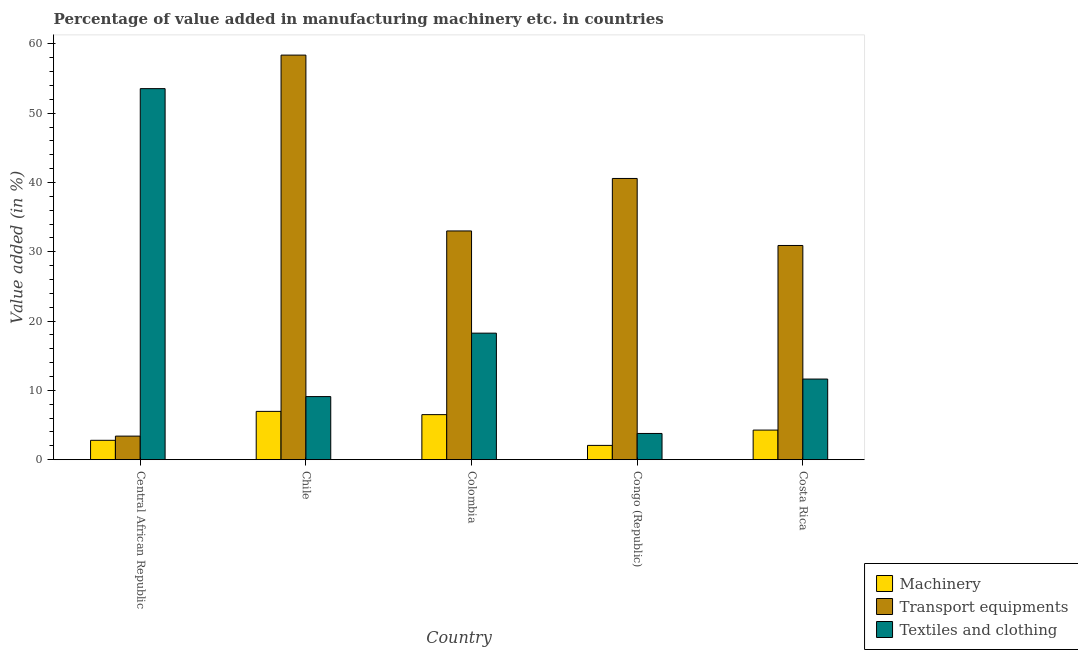How many groups of bars are there?
Keep it short and to the point. 5. Are the number of bars per tick equal to the number of legend labels?
Your answer should be compact. Yes. Are the number of bars on each tick of the X-axis equal?
Your answer should be compact. Yes. In how many cases, is the number of bars for a given country not equal to the number of legend labels?
Your response must be concise. 0. What is the value added in manufacturing machinery in Chile?
Ensure brevity in your answer.  6.97. Across all countries, what is the maximum value added in manufacturing transport equipments?
Your answer should be compact. 58.38. Across all countries, what is the minimum value added in manufacturing transport equipments?
Provide a succinct answer. 3.4. In which country was the value added in manufacturing textile and clothing minimum?
Provide a succinct answer. Congo (Republic). What is the total value added in manufacturing textile and clothing in the graph?
Make the answer very short. 96.33. What is the difference between the value added in manufacturing machinery in Congo (Republic) and that in Costa Rica?
Keep it short and to the point. -2.21. What is the difference between the value added in manufacturing textile and clothing in Central African Republic and the value added in manufacturing transport equipments in Costa Rica?
Your answer should be very brief. 22.63. What is the average value added in manufacturing machinery per country?
Provide a succinct answer. 4.52. What is the difference between the value added in manufacturing transport equipments and value added in manufacturing textile and clothing in Colombia?
Offer a very short reply. 14.75. In how many countries, is the value added in manufacturing transport equipments greater than 56 %?
Your answer should be compact. 1. What is the ratio of the value added in manufacturing textile and clothing in Congo (Republic) to that in Costa Rica?
Provide a succinct answer. 0.33. What is the difference between the highest and the second highest value added in manufacturing machinery?
Provide a short and direct response. 0.47. What is the difference between the highest and the lowest value added in manufacturing transport equipments?
Your answer should be very brief. 54.98. In how many countries, is the value added in manufacturing transport equipments greater than the average value added in manufacturing transport equipments taken over all countries?
Give a very brief answer. 2. What does the 3rd bar from the left in Congo (Republic) represents?
Offer a very short reply. Textiles and clothing. What does the 2nd bar from the right in Chile represents?
Make the answer very short. Transport equipments. Is it the case that in every country, the sum of the value added in manufacturing machinery and value added in manufacturing transport equipments is greater than the value added in manufacturing textile and clothing?
Give a very brief answer. No. How many bars are there?
Offer a very short reply. 15. How many countries are there in the graph?
Give a very brief answer. 5. Are the values on the major ticks of Y-axis written in scientific E-notation?
Keep it short and to the point. No. Does the graph contain any zero values?
Give a very brief answer. No. Does the graph contain grids?
Give a very brief answer. No. Where does the legend appear in the graph?
Offer a terse response. Bottom right. How many legend labels are there?
Your answer should be very brief. 3. What is the title of the graph?
Make the answer very short. Percentage of value added in manufacturing machinery etc. in countries. What is the label or title of the X-axis?
Offer a very short reply. Country. What is the label or title of the Y-axis?
Your answer should be very brief. Value added (in %). What is the Value added (in %) in Machinery in Central African Republic?
Your answer should be compact. 2.8. What is the Value added (in %) in Transport equipments in Central African Republic?
Provide a short and direct response. 3.4. What is the Value added (in %) of Textiles and clothing in Central African Republic?
Your answer should be compact. 53.54. What is the Value added (in %) in Machinery in Chile?
Give a very brief answer. 6.97. What is the Value added (in %) of Transport equipments in Chile?
Provide a succinct answer. 58.38. What is the Value added (in %) in Textiles and clothing in Chile?
Your response must be concise. 9.11. What is the Value added (in %) of Machinery in Colombia?
Your answer should be compact. 6.5. What is the Value added (in %) in Transport equipments in Colombia?
Ensure brevity in your answer.  33.01. What is the Value added (in %) of Textiles and clothing in Colombia?
Keep it short and to the point. 18.26. What is the Value added (in %) in Machinery in Congo (Republic)?
Keep it short and to the point. 2.06. What is the Value added (in %) in Transport equipments in Congo (Republic)?
Offer a terse response. 40.58. What is the Value added (in %) of Textiles and clothing in Congo (Republic)?
Provide a short and direct response. 3.79. What is the Value added (in %) of Machinery in Costa Rica?
Your response must be concise. 4.27. What is the Value added (in %) of Transport equipments in Costa Rica?
Your answer should be very brief. 30.91. What is the Value added (in %) of Textiles and clothing in Costa Rica?
Provide a short and direct response. 11.64. Across all countries, what is the maximum Value added (in %) of Machinery?
Provide a succinct answer. 6.97. Across all countries, what is the maximum Value added (in %) of Transport equipments?
Offer a terse response. 58.38. Across all countries, what is the maximum Value added (in %) of Textiles and clothing?
Your answer should be very brief. 53.54. Across all countries, what is the minimum Value added (in %) in Machinery?
Ensure brevity in your answer.  2.06. Across all countries, what is the minimum Value added (in %) of Transport equipments?
Keep it short and to the point. 3.4. Across all countries, what is the minimum Value added (in %) of Textiles and clothing?
Your response must be concise. 3.79. What is the total Value added (in %) in Machinery in the graph?
Provide a succinct answer. 22.61. What is the total Value added (in %) of Transport equipments in the graph?
Provide a short and direct response. 166.28. What is the total Value added (in %) of Textiles and clothing in the graph?
Give a very brief answer. 96.33. What is the difference between the Value added (in %) of Machinery in Central African Republic and that in Chile?
Provide a succinct answer. -4.17. What is the difference between the Value added (in %) in Transport equipments in Central African Republic and that in Chile?
Keep it short and to the point. -54.98. What is the difference between the Value added (in %) in Textiles and clothing in Central African Republic and that in Chile?
Provide a succinct answer. 44.44. What is the difference between the Value added (in %) in Machinery in Central African Republic and that in Colombia?
Provide a short and direct response. -3.7. What is the difference between the Value added (in %) of Transport equipments in Central African Republic and that in Colombia?
Your response must be concise. -29.6. What is the difference between the Value added (in %) in Textiles and clothing in Central African Republic and that in Colombia?
Make the answer very short. 35.28. What is the difference between the Value added (in %) in Machinery in Central African Republic and that in Congo (Republic)?
Offer a terse response. 0.74. What is the difference between the Value added (in %) of Transport equipments in Central African Republic and that in Congo (Republic)?
Your answer should be compact. -37.18. What is the difference between the Value added (in %) in Textiles and clothing in Central African Republic and that in Congo (Republic)?
Give a very brief answer. 49.76. What is the difference between the Value added (in %) in Machinery in Central African Republic and that in Costa Rica?
Ensure brevity in your answer.  -1.47. What is the difference between the Value added (in %) in Transport equipments in Central African Republic and that in Costa Rica?
Give a very brief answer. -27.51. What is the difference between the Value added (in %) of Textiles and clothing in Central African Republic and that in Costa Rica?
Provide a succinct answer. 41.91. What is the difference between the Value added (in %) in Machinery in Chile and that in Colombia?
Your response must be concise. 0.47. What is the difference between the Value added (in %) of Transport equipments in Chile and that in Colombia?
Your answer should be compact. 25.37. What is the difference between the Value added (in %) in Textiles and clothing in Chile and that in Colombia?
Make the answer very short. -9.15. What is the difference between the Value added (in %) in Machinery in Chile and that in Congo (Republic)?
Ensure brevity in your answer.  4.91. What is the difference between the Value added (in %) in Transport equipments in Chile and that in Congo (Republic)?
Make the answer very short. 17.8. What is the difference between the Value added (in %) of Textiles and clothing in Chile and that in Congo (Republic)?
Make the answer very short. 5.32. What is the difference between the Value added (in %) in Machinery in Chile and that in Costa Rica?
Offer a terse response. 2.7. What is the difference between the Value added (in %) of Transport equipments in Chile and that in Costa Rica?
Your answer should be compact. 27.47. What is the difference between the Value added (in %) in Textiles and clothing in Chile and that in Costa Rica?
Provide a short and direct response. -2.53. What is the difference between the Value added (in %) in Machinery in Colombia and that in Congo (Republic)?
Make the answer very short. 4.44. What is the difference between the Value added (in %) in Transport equipments in Colombia and that in Congo (Republic)?
Your answer should be compact. -7.57. What is the difference between the Value added (in %) of Textiles and clothing in Colombia and that in Congo (Republic)?
Your response must be concise. 14.48. What is the difference between the Value added (in %) in Machinery in Colombia and that in Costa Rica?
Your answer should be compact. 2.23. What is the difference between the Value added (in %) of Transport equipments in Colombia and that in Costa Rica?
Your response must be concise. 2.1. What is the difference between the Value added (in %) of Textiles and clothing in Colombia and that in Costa Rica?
Give a very brief answer. 6.62. What is the difference between the Value added (in %) in Machinery in Congo (Republic) and that in Costa Rica?
Your response must be concise. -2.21. What is the difference between the Value added (in %) of Transport equipments in Congo (Republic) and that in Costa Rica?
Offer a very short reply. 9.67. What is the difference between the Value added (in %) of Textiles and clothing in Congo (Republic) and that in Costa Rica?
Your response must be concise. -7.85. What is the difference between the Value added (in %) in Machinery in Central African Republic and the Value added (in %) in Transport equipments in Chile?
Your response must be concise. -55.58. What is the difference between the Value added (in %) of Machinery in Central African Republic and the Value added (in %) of Textiles and clothing in Chile?
Give a very brief answer. -6.31. What is the difference between the Value added (in %) of Transport equipments in Central African Republic and the Value added (in %) of Textiles and clothing in Chile?
Give a very brief answer. -5.7. What is the difference between the Value added (in %) in Machinery in Central African Republic and the Value added (in %) in Transport equipments in Colombia?
Provide a succinct answer. -30.21. What is the difference between the Value added (in %) in Machinery in Central African Republic and the Value added (in %) in Textiles and clothing in Colombia?
Ensure brevity in your answer.  -15.46. What is the difference between the Value added (in %) in Transport equipments in Central African Republic and the Value added (in %) in Textiles and clothing in Colombia?
Provide a short and direct response. -14.86. What is the difference between the Value added (in %) of Machinery in Central African Republic and the Value added (in %) of Transport equipments in Congo (Republic)?
Keep it short and to the point. -37.78. What is the difference between the Value added (in %) of Machinery in Central African Republic and the Value added (in %) of Textiles and clothing in Congo (Republic)?
Your answer should be compact. -0.99. What is the difference between the Value added (in %) in Transport equipments in Central African Republic and the Value added (in %) in Textiles and clothing in Congo (Republic)?
Give a very brief answer. -0.38. What is the difference between the Value added (in %) of Machinery in Central African Republic and the Value added (in %) of Transport equipments in Costa Rica?
Offer a terse response. -28.11. What is the difference between the Value added (in %) of Machinery in Central African Republic and the Value added (in %) of Textiles and clothing in Costa Rica?
Provide a short and direct response. -8.84. What is the difference between the Value added (in %) of Transport equipments in Central African Republic and the Value added (in %) of Textiles and clothing in Costa Rica?
Your answer should be very brief. -8.23. What is the difference between the Value added (in %) in Machinery in Chile and the Value added (in %) in Transport equipments in Colombia?
Offer a very short reply. -26.04. What is the difference between the Value added (in %) in Machinery in Chile and the Value added (in %) in Textiles and clothing in Colombia?
Keep it short and to the point. -11.29. What is the difference between the Value added (in %) in Transport equipments in Chile and the Value added (in %) in Textiles and clothing in Colombia?
Offer a very short reply. 40.12. What is the difference between the Value added (in %) of Machinery in Chile and the Value added (in %) of Transport equipments in Congo (Republic)?
Provide a succinct answer. -33.61. What is the difference between the Value added (in %) in Machinery in Chile and the Value added (in %) in Textiles and clothing in Congo (Republic)?
Provide a short and direct response. 3.19. What is the difference between the Value added (in %) of Transport equipments in Chile and the Value added (in %) of Textiles and clothing in Congo (Republic)?
Give a very brief answer. 54.6. What is the difference between the Value added (in %) of Machinery in Chile and the Value added (in %) of Transport equipments in Costa Rica?
Provide a short and direct response. -23.94. What is the difference between the Value added (in %) of Machinery in Chile and the Value added (in %) of Textiles and clothing in Costa Rica?
Your answer should be very brief. -4.67. What is the difference between the Value added (in %) of Transport equipments in Chile and the Value added (in %) of Textiles and clothing in Costa Rica?
Offer a very short reply. 46.74. What is the difference between the Value added (in %) of Machinery in Colombia and the Value added (in %) of Transport equipments in Congo (Republic)?
Your response must be concise. -34.08. What is the difference between the Value added (in %) of Machinery in Colombia and the Value added (in %) of Textiles and clothing in Congo (Republic)?
Keep it short and to the point. 2.72. What is the difference between the Value added (in %) in Transport equipments in Colombia and the Value added (in %) in Textiles and clothing in Congo (Republic)?
Offer a terse response. 29.22. What is the difference between the Value added (in %) in Machinery in Colombia and the Value added (in %) in Transport equipments in Costa Rica?
Your response must be concise. -24.41. What is the difference between the Value added (in %) in Machinery in Colombia and the Value added (in %) in Textiles and clothing in Costa Rica?
Make the answer very short. -5.13. What is the difference between the Value added (in %) of Transport equipments in Colombia and the Value added (in %) of Textiles and clothing in Costa Rica?
Give a very brief answer. 21.37. What is the difference between the Value added (in %) of Machinery in Congo (Republic) and the Value added (in %) of Transport equipments in Costa Rica?
Ensure brevity in your answer.  -28.85. What is the difference between the Value added (in %) of Machinery in Congo (Republic) and the Value added (in %) of Textiles and clothing in Costa Rica?
Provide a short and direct response. -9.57. What is the difference between the Value added (in %) in Transport equipments in Congo (Republic) and the Value added (in %) in Textiles and clothing in Costa Rica?
Keep it short and to the point. 28.94. What is the average Value added (in %) of Machinery per country?
Offer a terse response. 4.52. What is the average Value added (in %) in Transport equipments per country?
Your response must be concise. 33.26. What is the average Value added (in %) in Textiles and clothing per country?
Your answer should be compact. 19.27. What is the difference between the Value added (in %) in Machinery and Value added (in %) in Transport equipments in Central African Republic?
Give a very brief answer. -0.61. What is the difference between the Value added (in %) of Machinery and Value added (in %) of Textiles and clothing in Central African Republic?
Your response must be concise. -50.74. What is the difference between the Value added (in %) of Transport equipments and Value added (in %) of Textiles and clothing in Central African Republic?
Keep it short and to the point. -50.14. What is the difference between the Value added (in %) in Machinery and Value added (in %) in Transport equipments in Chile?
Make the answer very short. -51.41. What is the difference between the Value added (in %) in Machinery and Value added (in %) in Textiles and clothing in Chile?
Ensure brevity in your answer.  -2.14. What is the difference between the Value added (in %) in Transport equipments and Value added (in %) in Textiles and clothing in Chile?
Offer a terse response. 49.27. What is the difference between the Value added (in %) of Machinery and Value added (in %) of Transport equipments in Colombia?
Give a very brief answer. -26.5. What is the difference between the Value added (in %) in Machinery and Value added (in %) in Textiles and clothing in Colombia?
Provide a succinct answer. -11.76. What is the difference between the Value added (in %) in Transport equipments and Value added (in %) in Textiles and clothing in Colombia?
Provide a short and direct response. 14.75. What is the difference between the Value added (in %) in Machinery and Value added (in %) in Transport equipments in Congo (Republic)?
Your answer should be very brief. -38.52. What is the difference between the Value added (in %) in Machinery and Value added (in %) in Textiles and clothing in Congo (Republic)?
Your answer should be compact. -1.72. What is the difference between the Value added (in %) in Transport equipments and Value added (in %) in Textiles and clothing in Congo (Republic)?
Give a very brief answer. 36.8. What is the difference between the Value added (in %) in Machinery and Value added (in %) in Transport equipments in Costa Rica?
Make the answer very short. -26.64. What is the difference between the Value added (in %) in Machinery and Value added (in %) in Textiles and clothing in Costa Rica?
Your answer should be very brief. -7.36. What is the difference between the Value added (in %) of Transport equipments and Value added (in %) of Textiles and clothing in Costa Rica?
Give a very brief answer. 19.27. What is the ratio of the Value added (in %) in Machinery in Central African Republic to that in Chile?
Give a very brief answer. 0.4. What is the ratio of the Value added (in %) in Transport equipments in Central African Republic to that in Chile?
Offer a terse response. 0.06. What is the ratio of the Value added (in %) of Textiles and clothing in Central African Republic to that in Chile?
Offer a very short reply. 5.88. What is the ratio of the Value added (in %) of Machinery in Central African Republic to that in Colombia?
Offer a very short reply. 0.43. What is the ratio of the Value added (in %) of Transport equipments in Central African Republic to that in Colombia?
Provide a short and direct response. 0.1. What is the ratio of the Value added (in %) in Textiles and clothing in Central African Republic to that in Colombia?
Provide a short and direct response. 2.93. What is the ratio of the Value added (in %) of Machinery in Central African Republic to that in Congo (Republic)?
Make the answer very short. 1.36. What is the ratio of the Value added (in %) of Transport equipments in Central African Republic to that in Congo (Republic)?
Offer a very short reply. 0.08. What is the ratio of the Value added (in %) in Textiles and clothing in Central African Republic to that in Congo (Republic)?
Keep it short and to the point. 14.14. What is the ratio of the Value added (in %) of Machinery in Central African Republic to that in Costa Rica?
Your response must be concise. 0.66. What is the ratio of the Value added (in %) in Transport equipments in Central African Republic to that in Costa Rica?
Ensure brevity in your answer.  0.11. What is the ratio of the Value added (in %) in Textiles and clothing in Central African Republic to that in Costa Rica?
Your answer should be very brief. 4.6. What is the ratio of the Value added (in %) of Machinery in Chile to that in Colombia?
Make the answer very short. 1.07. What is the ratio of the Value added (in %) of Transport equipments in Chile to that in Colombia?
Offer a terse response. 1.77. What is the ratio of the Value added (in %) in Textiles and clothing in Chile to that in Colombia?
Your answer should be compact. 0.5. What is the ratio of the Value added (in %) of Machinery in Chile to that in Congo (Republic)?
Give a very brief answer. 3.38. What is the ratio of the Value added (in %) in Transport equipments in Chile to that in Congo (Republic)?
Your answer should be very brief. 1.44. What is the ratio of the Value added (in %) of Textiles and clothing in Chile to that in Congo (Republic)?
Provide a short and direct response. 2.41. What is the ratio of the Value added (in %) of Machinery in Chile to that in Costa Rica?
Offer a very short reply. 1.63. What is the ratio of the Value added (in %) in Transport equipments in Chile to that in Costa Rica?
Offer a terse response. 1.89. What is the ratio of the Value added (in %) in Textiles and clothing in Chile to that in Costa Rica?
Provide a short and direct response. 0.78. What is the ratio of the Value added (in %) in Machinery in Colombia to that in Congo (Republic)?
Keep it short and to the point. 3.15. What is the ratio of the Value added (in %) of Transport equipments in Colombia to that in Congo (Republic)?
Provide a short and direct response. 0.81. What is the ratio of the Value added (in %) of Textiles and clothing in Colombia to that in Congo (Republic)?
Your answer should be very brief. 4.82. What is the ratio of the Value added (in %) of Machinery in Colombia to that in Costa Rica?
Your response must be concise. 1.52. What is the ratio of the Value added (in %) of Transport equipments in Colombia to that in Costa Rica?
Provide a succinct answer. 1.07. What is the ratio of the Value added (in %) of Textiles and clothing in Colombia to that in Costa Rica?
Your response must be concise. 1.57. What is the ratio of the Value added (in %) of Machinery in Congo (Republic) to that in Costa Rica?
Give a very brief answer. 0.48. What is the ratio of the Value added (in %) of Transport equipments in Congo (Republic) to that in Costa Rica?
Provide a succinct answer. 1.31. What is the ratio of the Value added (in %) of Textiles and clothing in Congo (Republic) to that in Costa Rica?
Your answer should be very brief. 0.33. What is the difference between the highest and the second highest Value added (in %) of Machinery?
Provide a short and direct response. 0.47. What is the difference between the highest and the second highest Value added (in %) of Transport equipments?
Your answer should be very brief. 17.8. What is the difference between the highest and the second highest Value added (in %) of Textiles and clothing?
Ensure brevity in your answer.  35.28. What is the difference between the highest and the lowest Value added (in %) in Machinery?
Offer a terse response. 4.91. What is the difference between the highest and the lowest Value added (in %) in Transport equipments?
Offer a very short reply. 54.98. What is the difference between the highest and the lowest Value added (in %) in Textiles and clothing?
Offer a very short reply. 49.76. 